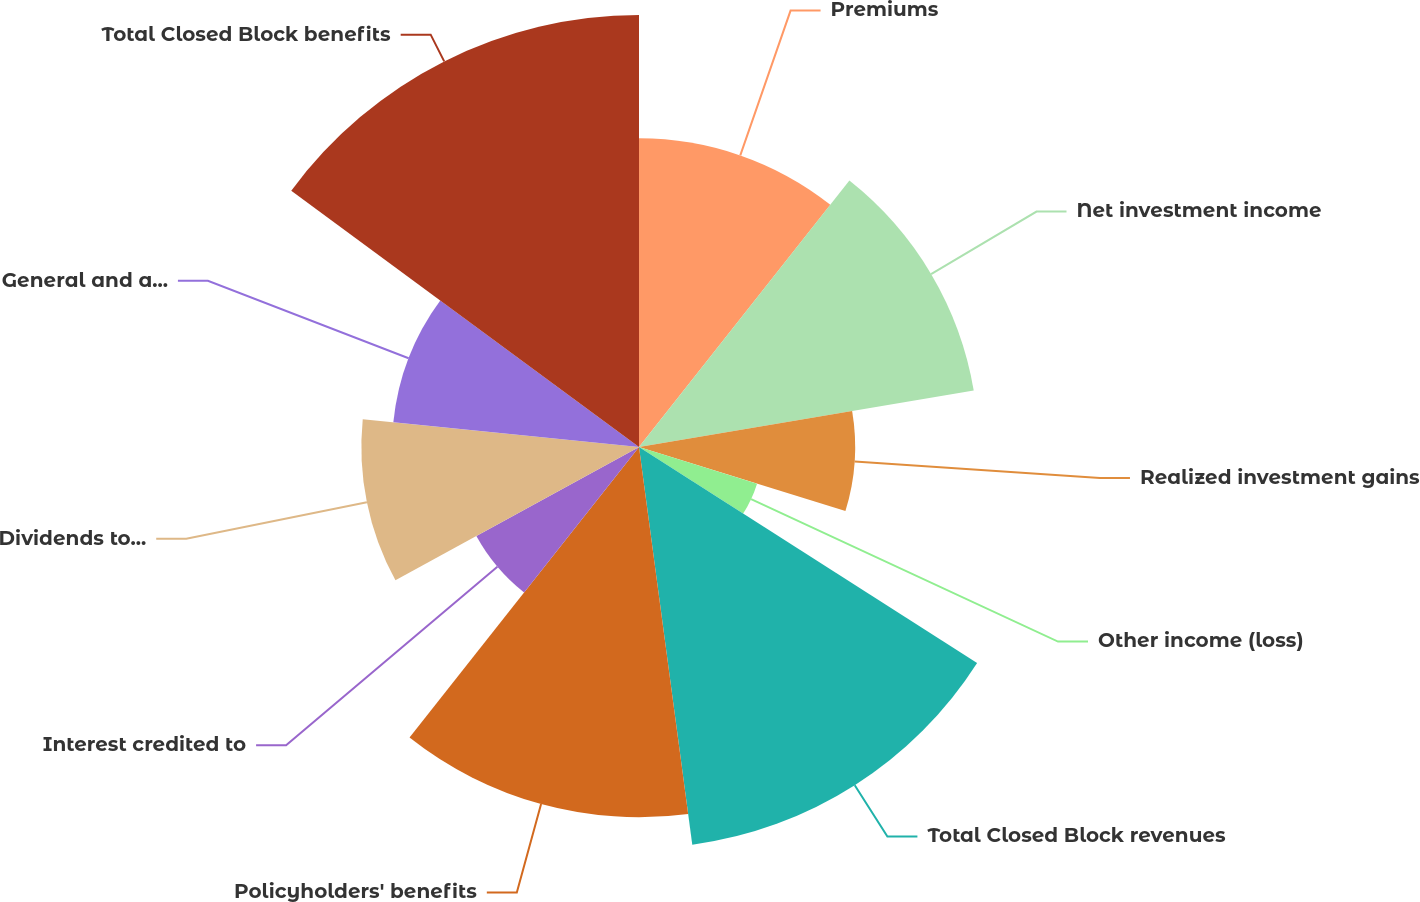Convert chart to OTSL. <chart><loc_0><loc_0><loc_500><loc_500><pie_chart><fcel>Premiums<fcel>Net investment income<fcel>Realized investment gains<fcel>Other income (loss)<fcel>Total Closed Block revenues<fcel>Policyholders' benefits<fcel>Interest credited to<fcel>Dividends to policyholders<fcel>General and administrative<fcel>Total Closed Block benefits<nl><fcel>10.64%<fcel>11.7%<fcel>7.45%<fcel>4.26%<fcel>13.83%<fcel>12.76%<fcel>6.39%<fcel>9.57%<fcel>8.51%<fcel>14.89%<nl></chart> 